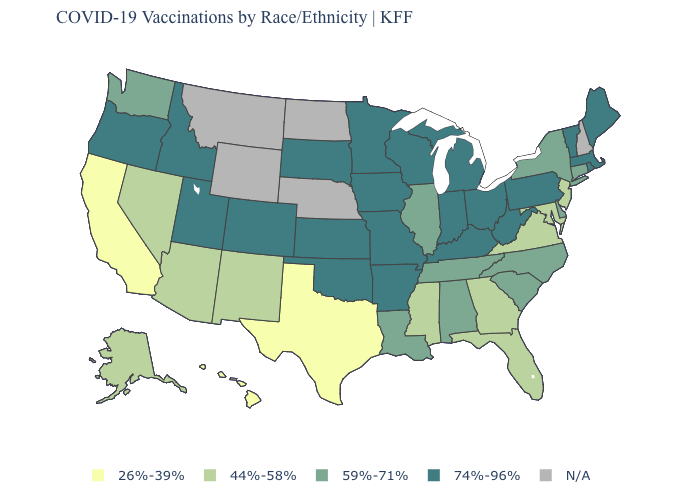Name the states that have a value in the range 59%-71%?
Concise answer only. Alabama, Connecticut, Delaware, Illinois, Louisiana, New York, North Carolina, South Carolina, Tennessee, Washington. Is the legend a continuous bar?
Answer briefly. No. What is the value of Connecticut?
Write a very short answer. 59%-71%. Which states have the lowest value in the USA?
Short answer required. California, Hawaii, Texas. Name the states that have a value in the range 44%-58%?
Concise answer only. Alaska, Arizona, Florida, Georgia, Maryland, Mississippi, Nevada, New Jersey, New Mexico, Virginia. Name the states that have a value in the range N/A?
Write a very short answer. Montana, Nebraska, New Hampshire, North Dakota, Wyoming. What is the highest value in the South ?
Quick response, please. 74%-96%. Name the states that have a value in the range N/A?
Be succinct. Montana, Nebraska, New Hampshire, North Dakota, Wyoming. What is the value of Nevada?
Short answer required. 44%-58%. Which states have the lowest value in the MidWest?
Write a very short answer. Illinois. What is the value of Missouri?
Quick response, please. 74%-96%. Among the states that border North Carolina , which have the lowest value?
Quick response, please. Georgia, Virginia. What is the value of Texas?
Keep it brief. 26%-39%. What is the value of North Dakota?
Answer briefly. N/A. Does the first symbol in the legend represent the smallest category?
Keep it brief. Yes. 